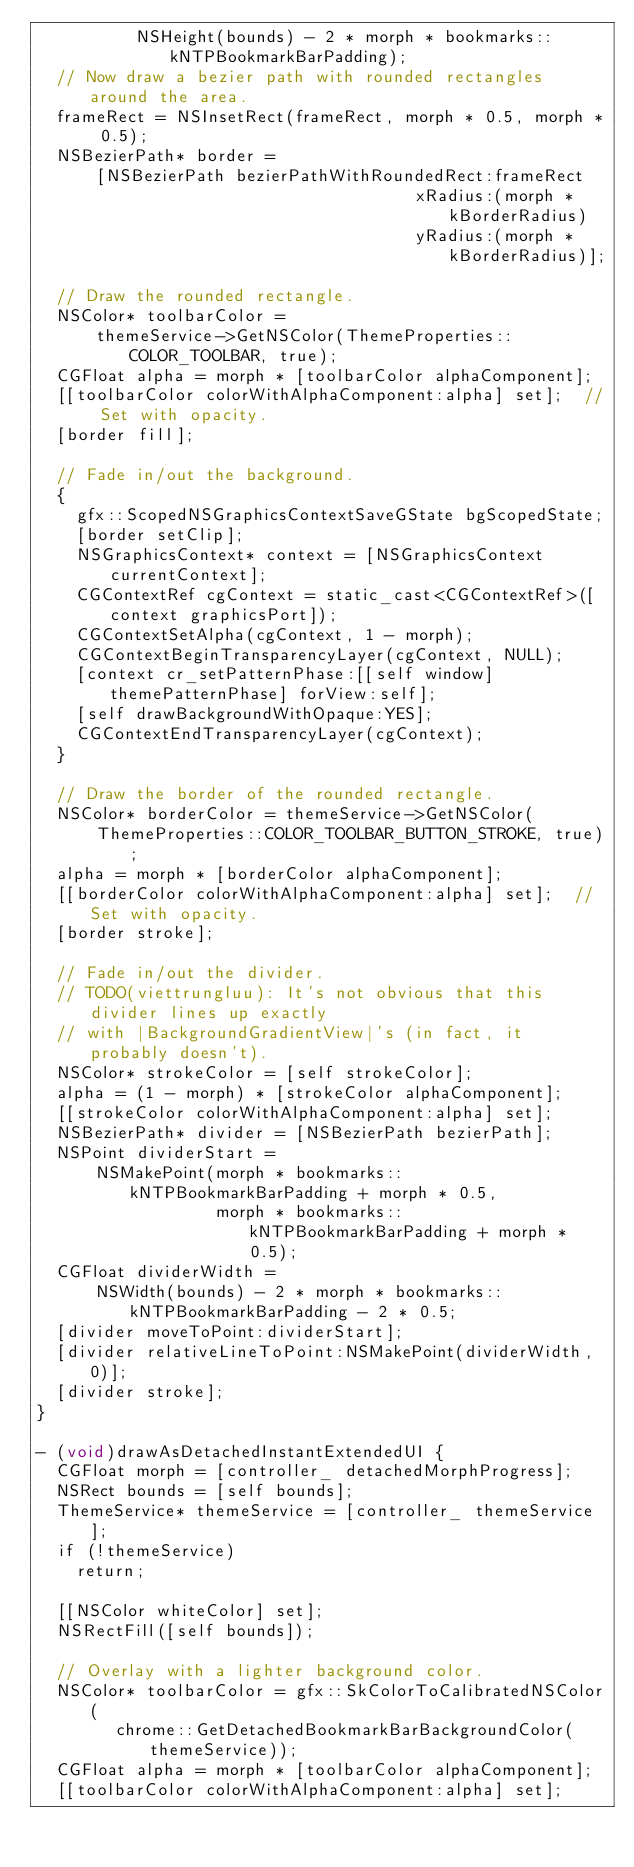<code> <loc_0><loc_0><loc_500><loc_500><_ObjectiveC_>          NSHeight(bounds) - 2 * morph * bookmarks::kNTPBookmarkBarPadding);
  // Now draw a bezier path with rounded rectangles around the area.
  frameRect = NSInsetRect(frameRect, morph * 0.5, morph * 0.5);
  NSBezierPath* border =
      [NSBezierPath bezierPathWithRoundedRect:frameRect
                                      xRadius:(morph * kBorderRadius)
                                      yRadius:(morph * kBorderRadius)];

  // Draw the rounded rectangle.
  NSColor* toolbarColor =
      themeService->GetNSColor(ThemeProperties::COLOR_TOOLBAR, true);
  CGFloat alpha = morph * [toolbarColor alphaComponent];
  [[toolbarColor colorWithAlphaComponent:alpha] set];  // Set with opacity.
  [border fill];

  // Fade in/out the background.
  {
    gfx::ScopedNSGraphicsContextSaveGState bgScopedState;
    [border setClip];
    NSGraphicsContext* context = [NSGraphicsContext currentContext];
    CGContextRef cgContext = static_cast<CGContextRef>([context graphicsPort]);
    CGContextSetAlpha(cgContext, 1 - morph);
    CGContextBeginTransparencyLayer(cgContext, NULL);
    [context cr_setPatternPhase:[[self window] themePatternPhase] forView:self];
    [self drawBackgroundWithOpaque:YES];
    CGContextEndTransparencyLayer(cgContext);
  }

  // Draw the border of the rounded rectangle.
  NSColor* borderColor = themeService->GetNSColor(
      ThemeProperties::COLOR_TOOLBAR_BUTTON_STROKE, true);
  alpha = morph * [borderColor alphaComponent];
  [[borderColor colorWithAlphaComponent:alpha] set];  // Set with opacity.
  [border stroke];

  // Fade in/out the divider.
  // TODO(viettrungluu): It's not obvious that this divider lines up exactly
  // with |BackgroundGradientView|'s (in fact, it probably doesn't).
  NSColor* strokeColor = [self strokeColor];
  alpha = (1 - morph) * [strokeColor alphaComponent];
  [[strokeColor colorWithAlphaComponent:alpha] set];
  NSBezierPath* divider = [NSBezierPath bezierPath];
  NSPoint dividerStart =
      NSMakePoint(morph * bookmarks::kNTPBookmarkBarPadding + morph * 0.5,
                  morph * bookmarks::kNTPBookmarkBarPadding + morph * 0.5);
  CGFloat dividerWidth =
      NSWidth(bounds) - 2 * morph * bookmarks::kNTPBookmarkBarPadding - 2 * 0.5;
  [divider moveToPoint:dividerStart];
  [divider relativeLineToPoint:NSMakePoint(dividerWidth, 0)];
  [divider stroke];
}

- (void)drawAsDetachedInstantExtendedUI {
  CGFloat morph = [controller_ detachedMorphProgress];
  NSRect bounds = [self bounds];
  ThemeService* themeService = [controller_ themeService];
  if (!themeService)
    return;

  [[NSColor whiteColor] set];
  NSRectFill([self bounds]);

  // Overlay with a lighter background color.
  NSColor* toolbarColor = gfx::SkColorToCalibratedNSColor(
        chrome::GetDetachedBookmarkBarBackgroundColor(themeService));
  CGFloat alpha = morph * [toolbarColor alphaComponent];
  [[toolbarColor colorWithAlphaComponent:alpha] set];</code> 